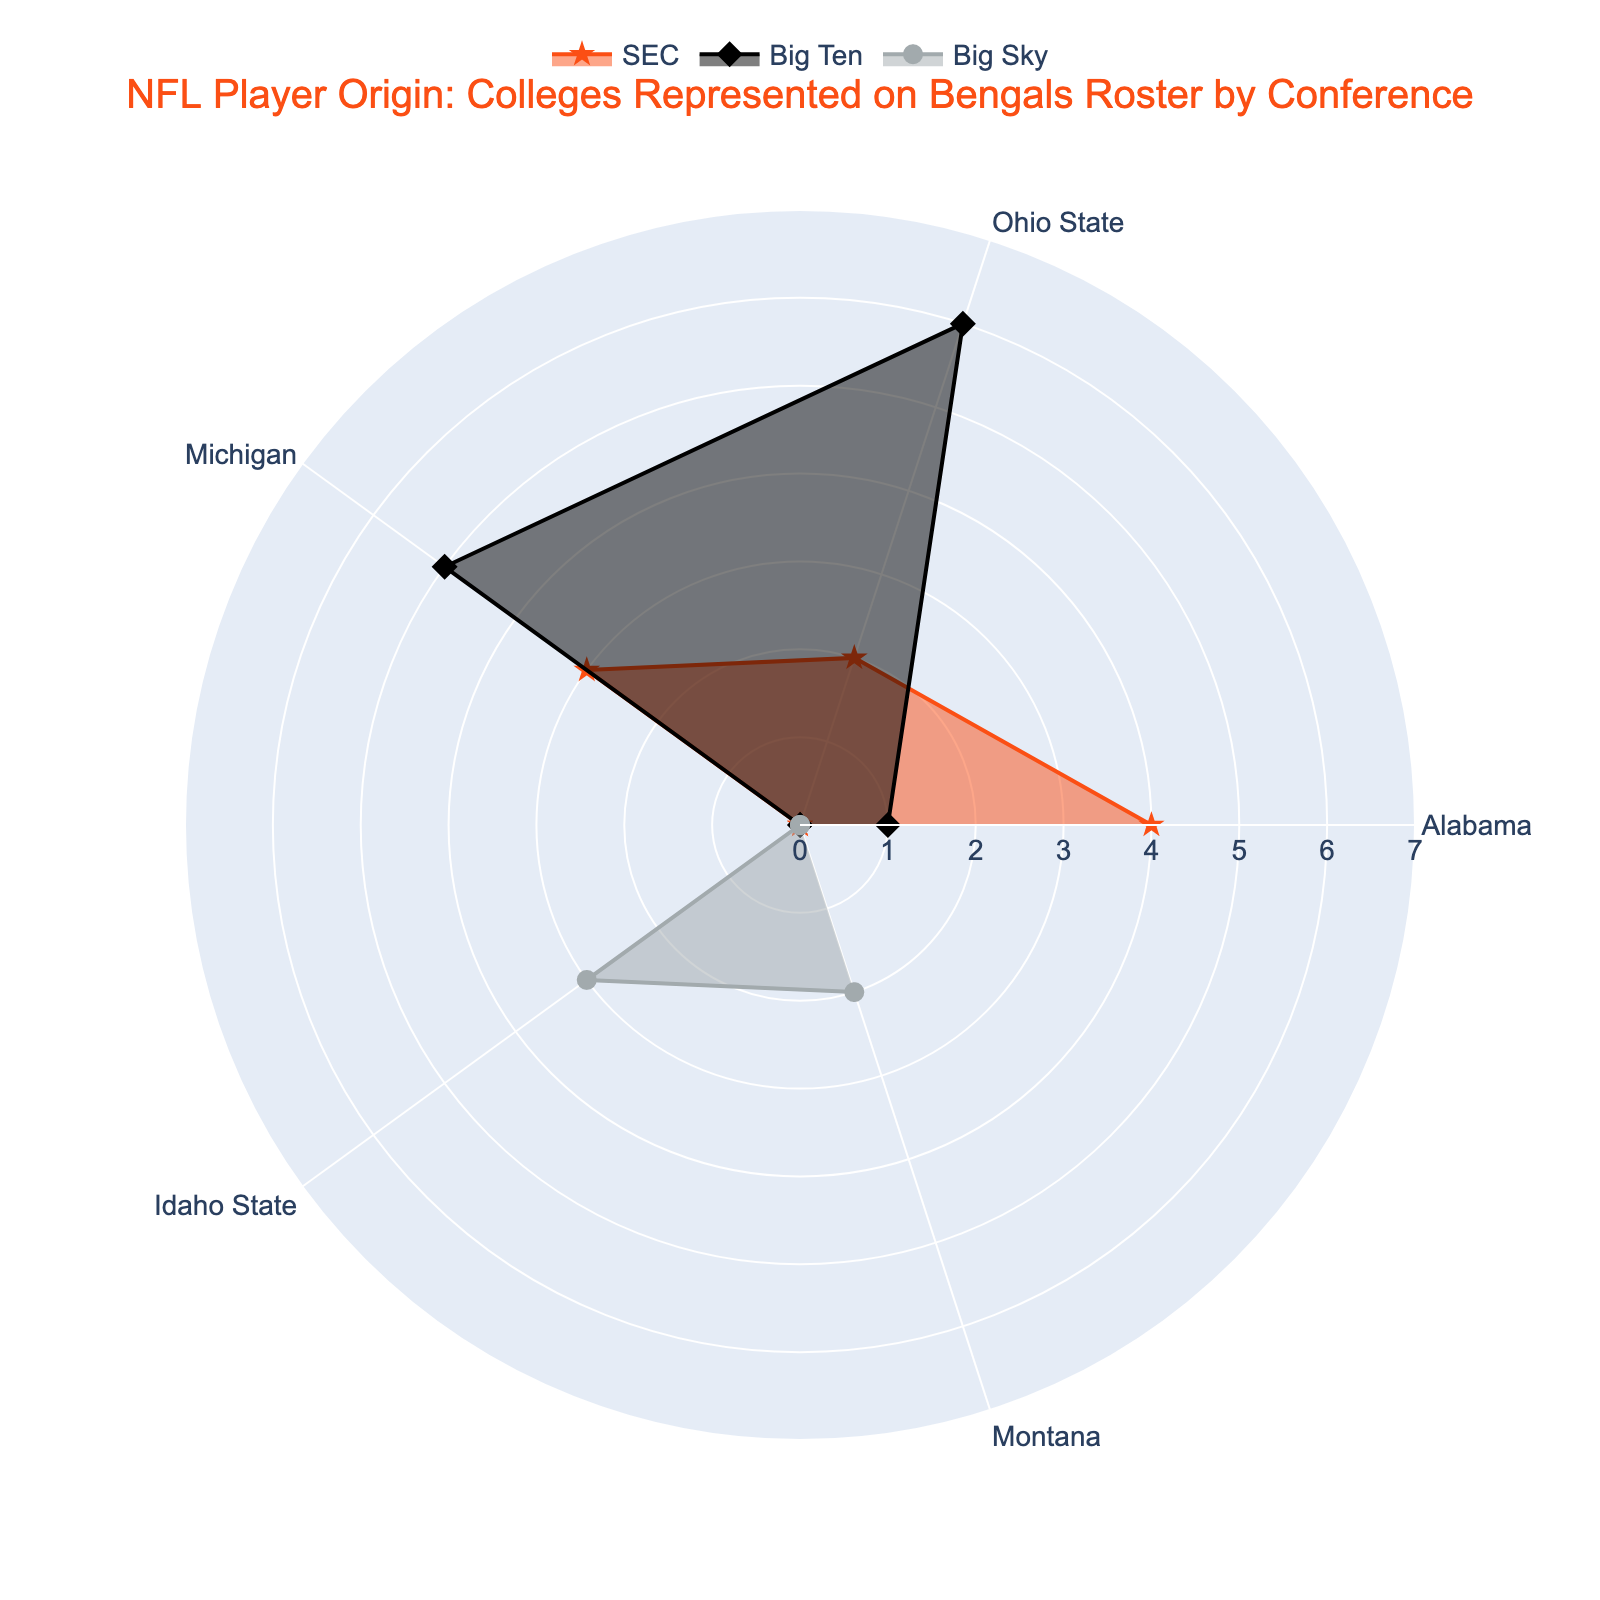What's the title of the radar chart? The title of the radar chart is displayed at the top of the figure in a larger and bold font. It reads: "NFL Player Origin: Colleges Represented on Bengals Roster by Conference".
Answer: NFL Player Origin: Colleges Represented on Bengals Roster by Conference Which conference has the highest number of players from Ohio State? Look at the radar chart's Ohio State segment for each conference. The Big Ten line extends the furthest, indicating it has the highest number of players from Ohio State.
Answer: Big Ten How many Idaho State players are represented on the Bengals roster, and under which conference are they categorized? The radar chart has an Idaho State segment. The values for each conference show that Idaho State has 3 players, and they fall under the Big Sky conference.
Answer: 3, Big Sky Which college has the lowest representation in the SEC conference? Look at the radar chart's SEC values for each college. Idaho State has a value of 0, making it the lowest representation in the SEC.
Answer: Idaho State What is the average number of players from Michigan across all conferences? Locate Michigan's values for each conference on the radar chart: SEC (3), Big Ten (5), and Big Sky (0). Sum these values (3 + 5 + 0 = 8) and divide by the number of conferences (3) to find the average.
Answer: 2.67 Compare the number of players from Alabama in the SEC to those from Ohio State in the Big Ten. Which is higher? Look at the values for Alabama in the SEC (4) and Ohio State in the Big Ten (6). Ohio State in the Big Ten has more players.
Answer: Ohio State in the Big Ten What is the combined total of players from Montana and Michigan in the Big Sky conference? Look at the Big Sky values for both Montana (2) and Michigan (0). Sum these values to get the total: 2 + 0 = 2.
Answer: 2 Which college has the highest representation overall across all conferences? Look for the college with the highest sum of values across all conferences. Ohio State has 2 (SEC) + 6 (Big Ten) + 0 (Big Sky) = 8, which is higher than others.
Answer: Ohio State Which conference has the most diverse representation of colleges in terms of number of players? Compare the range of values for each conference. The SEC has 4 (Alabama), 2 (Ohio State), and 3 (Michigan), making it the most diverse.
Answer: SEC 